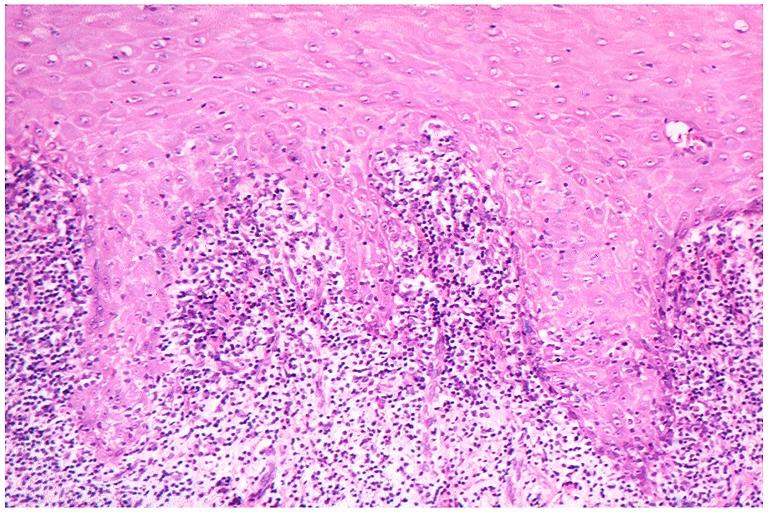what is present?
Answer the question using a single word or phrase. Oral 